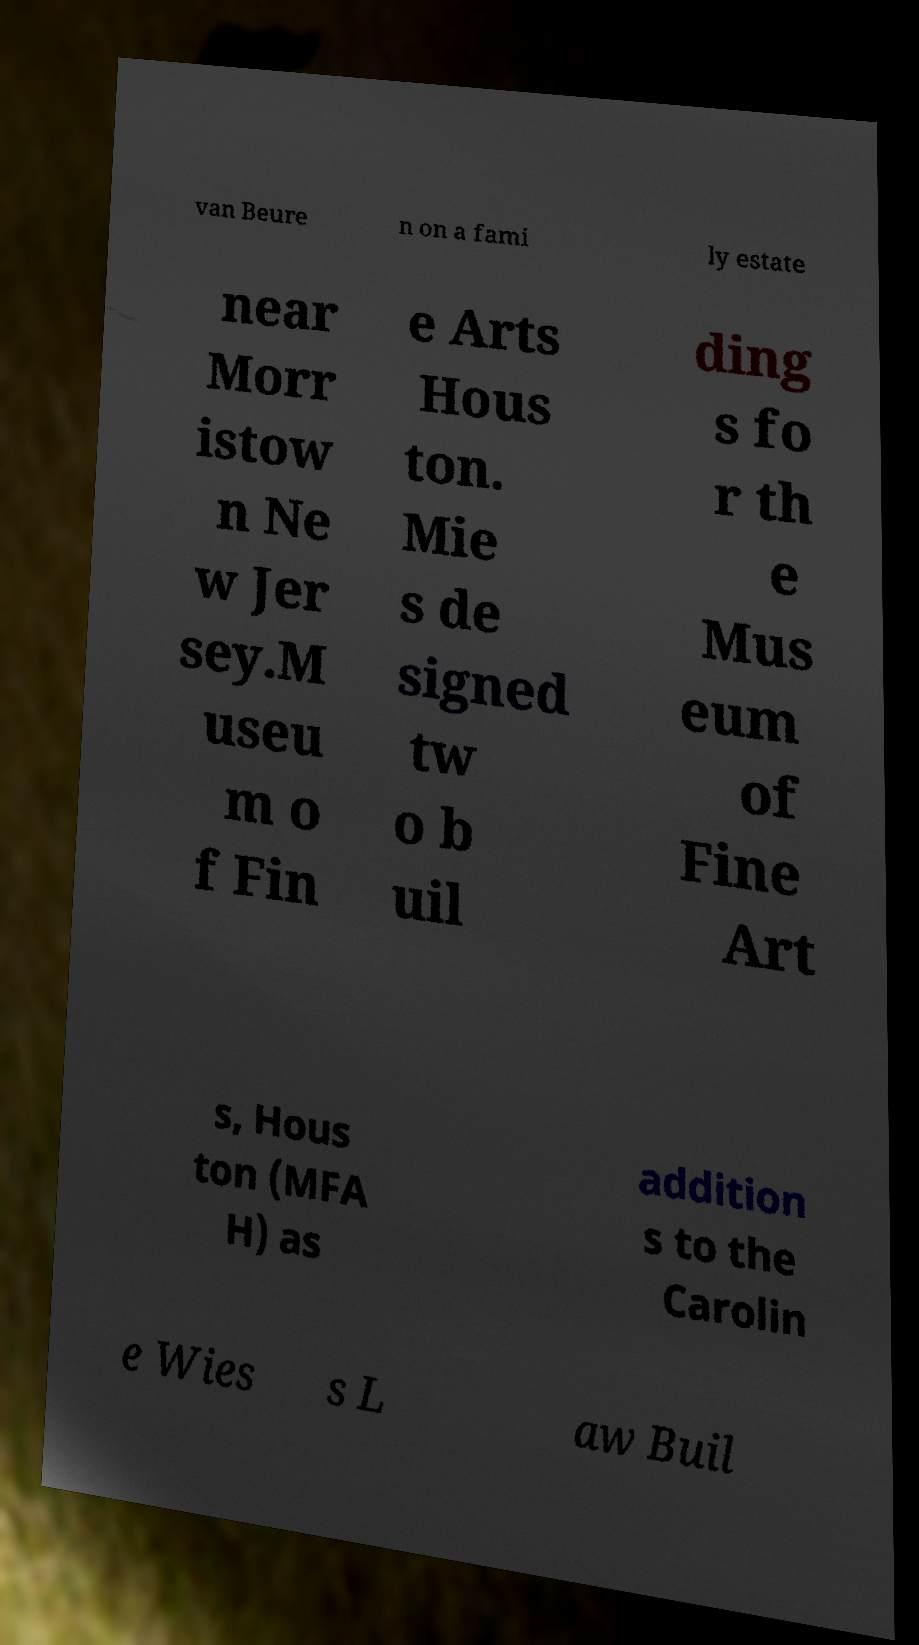Could you extract and type out the text from this image? van Beure n on a fami ly estate near Morr istow n Ne w Jer sey.M useu m o f Fin e Arts Hous ton. Mie s de signed tw o b uil ding s fo r th e Mus eum of Fine Art s, Hous ton (MFA H) as addition s to the Carolin e Wies s L aw Buil 